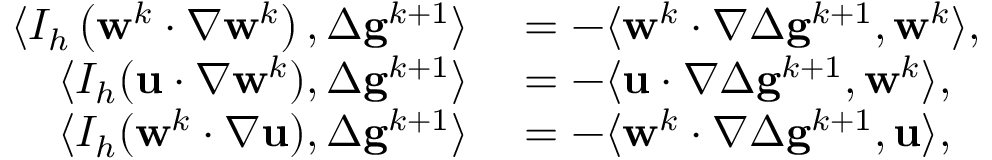Convert formula to latex. <formula><loc_0><loc_0><loc_500><loc_500>\begin{array} { r l } { \langle I _ { h } \left ( w ^ { k } \cdot \nabla w ^ { k } \right ) , \Delta g ^ { k + 1 } \rangle } & = - \langle w ^ { k } \cdot \nabla \Delta g ^ { k + 1 } , w ^ { k } \rangle , } \\ { \langle I _ { h } ( u \cdot \nabla w ^ { k } ) , \Delta g ^ { k + 1 } \rangle } & = - \langle u \cdot \nabla \Delta g ^ { k + 1 } , w ^ { k } \rangle , } \\ { \langle I _ { h } ( w ^ { k } \cdot \nabla u ) , \Delta g ^ { k + 1 } \rangle } & = - \langle w ^ { k } \cdot \nabla \Delta g ^ { k + 1 } , u \rangle , } \end{array}</formula> 